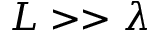<formula> <loc_0><loc_0><loc_500><loc_500>L > > \lambda</formula> 